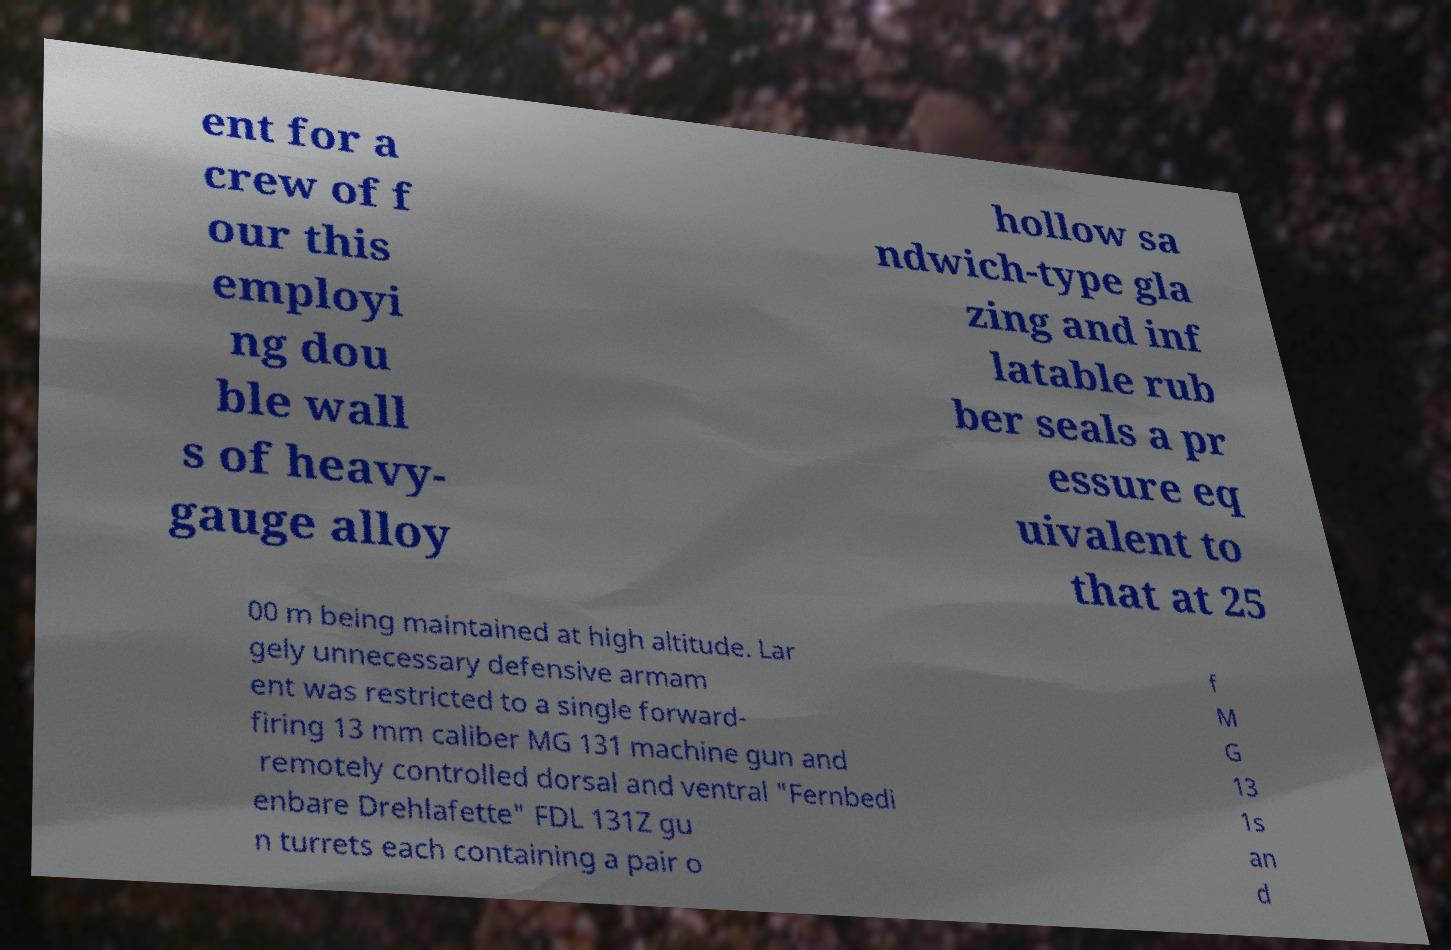Please identify and transcribe the text found in this image. ent for a crew of f our this employi ng dou ble wall s of heavy- gauge alloy hollow sa ndwich-type gla zing and inf latable rub ber seals a pr essure eq uivalent to that at 25 00 m being maintained at high altitude. Lar gely unnecessary defensive armam ent was restricted to a single forward- firing 13 mm caliber MG 131 machine gun and remotely controlled dorsal and ventral "Fernbedi enbare Drehlafette" FDL 131Z gu n turrets each containing a pair o f M G 13 1s an d 